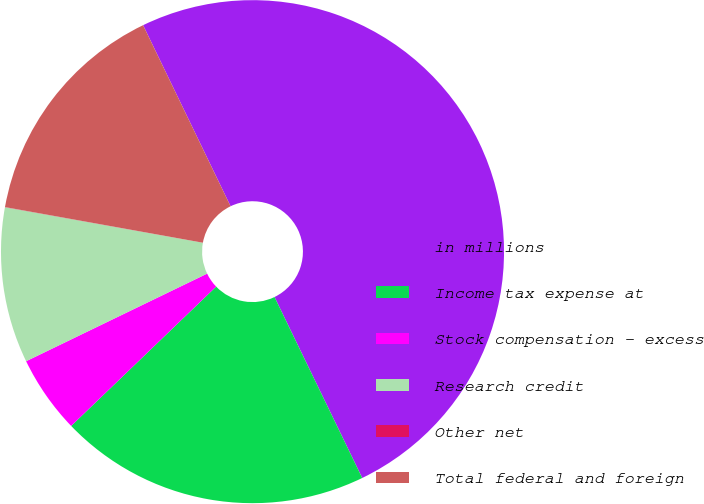<chart> <loc_0><loc_0><loc_500><loc_500><pie_chart><fcel>in millions<fcel>Income tax expense at<fcel>Stock compensation - excess<fcel>Research credit<fcel>Other net<fcel>Total federal and foreign<nl><fcel>49.98%<fcel>20.0%<fcel>5.01%<fcel>10.0%<fcel>0.01%<fcel>15.0%<nl></chart> 